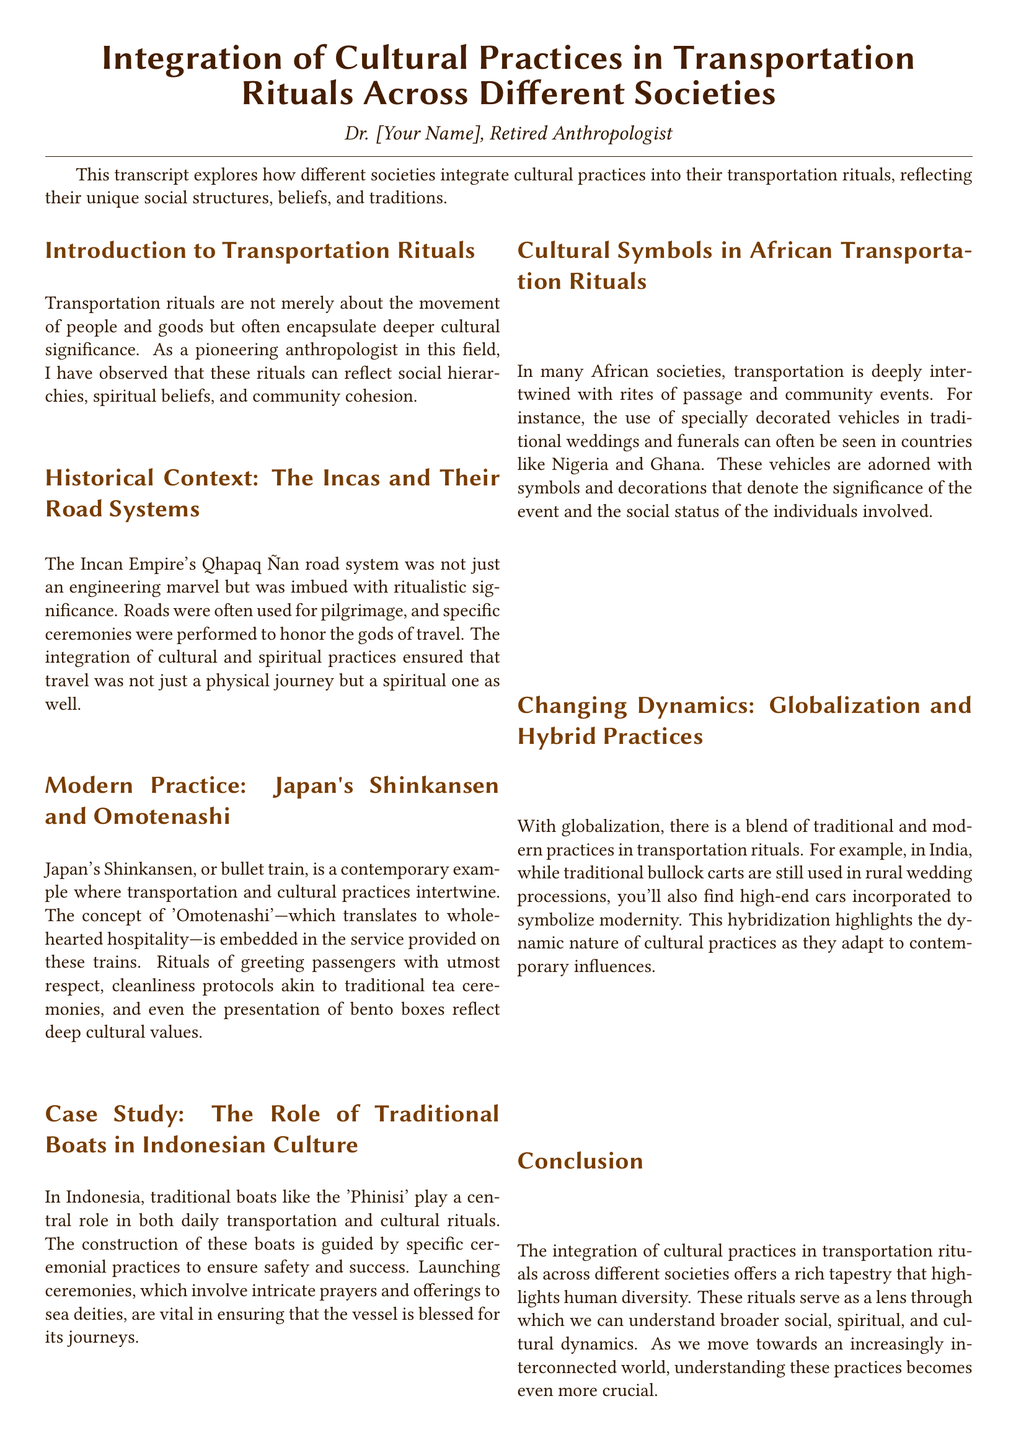What is the title of the document? The title is specifically stated at the beginning of the document.
Answer: Integration of Cultural Practices in Transportation Rituals Across Different Societies Who is the author of the document? The author is identified in the introduction section.
Answer: Dr. [Your Name] What is the primary focus of the transcript? The transcript explores the integration of cultural practices in transportation rituals across different societies.
Answer: Cultural practices in transportation rituals Which ancient civilization's road system is discussed? The document mentions the Qhapaq Ñan road system in relation to the Incas.
Answer: Incas What Japanese concept is associated with the Shinkansen? The text explicitly references a cultural concept tied to the service on the Shinkansen.
Answer: Omotenashi What type of traditional boats are highlighted in Indonesian culture? The specific type of boats is mentioned in the context of cultural rituals.
Answer: Phinisi What role do decorated vehicles play in African societies? The document explains their significance in traditional events like weddings and funerals.
Answer: Rites of passage How has globalization affected transportation rituals? The impact of globalization is explored in relation to the blending of practices.
Answer: Hybrid practices What is the focus of the case study within the document? The case study elaborates on Indonesian culture, specifically related to transportation.
Answer: Traditional boats in Indonesian culture 